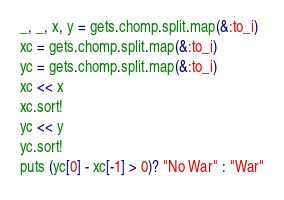<code> <loc_0><loc_0><loc_500><loc_500><_Ruby_>_, _, x, y = gets.chomp.split.map(&:to_i)
xc = gets.chomp.split.map(&:to_i)
yc = gets.chomp.split.map(&:to_i)
xc << x
xc.sort!
yc << y
yc.sort!
puts (yc[0] - xc[-1] > 0)? "No War" : "War"</code> 